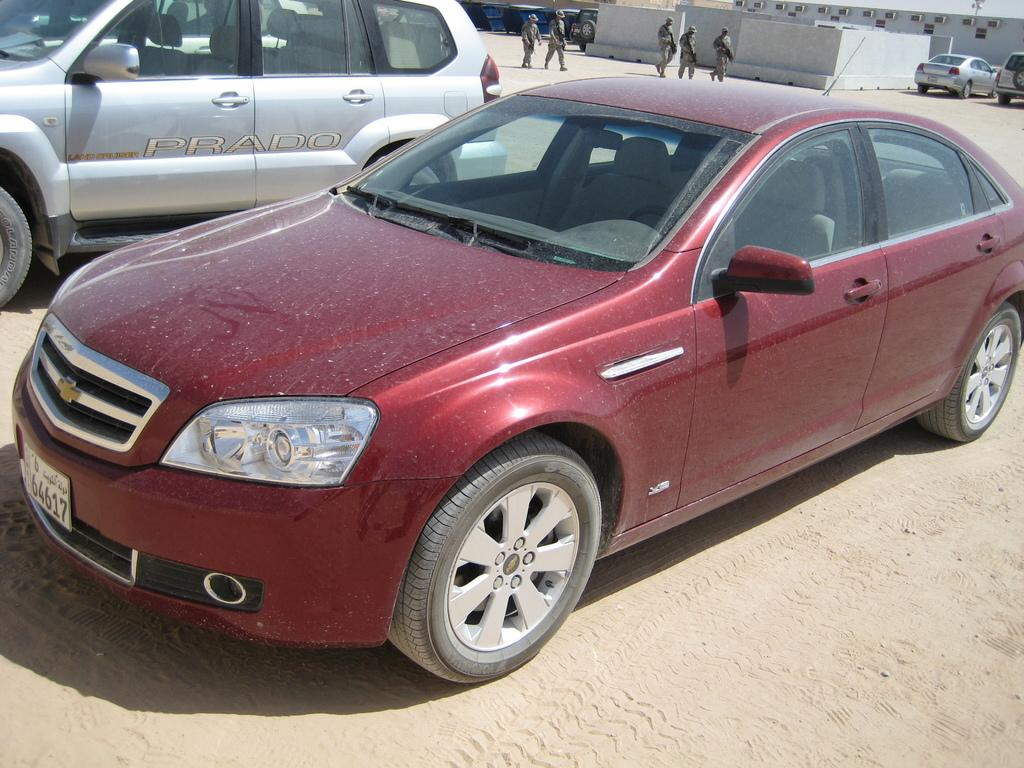What can be seen in the center of the image? There are two vehicles in the center of the image. What is visible in the background of the image? There is a building and vehicles in the background of the image. Are there any people present in the image? Yes, there are people standing in the background of the image. What type of flower is growing near the vehicles in the image? There is no flower present in the image; it features two vehicles and a background with a building and people. 